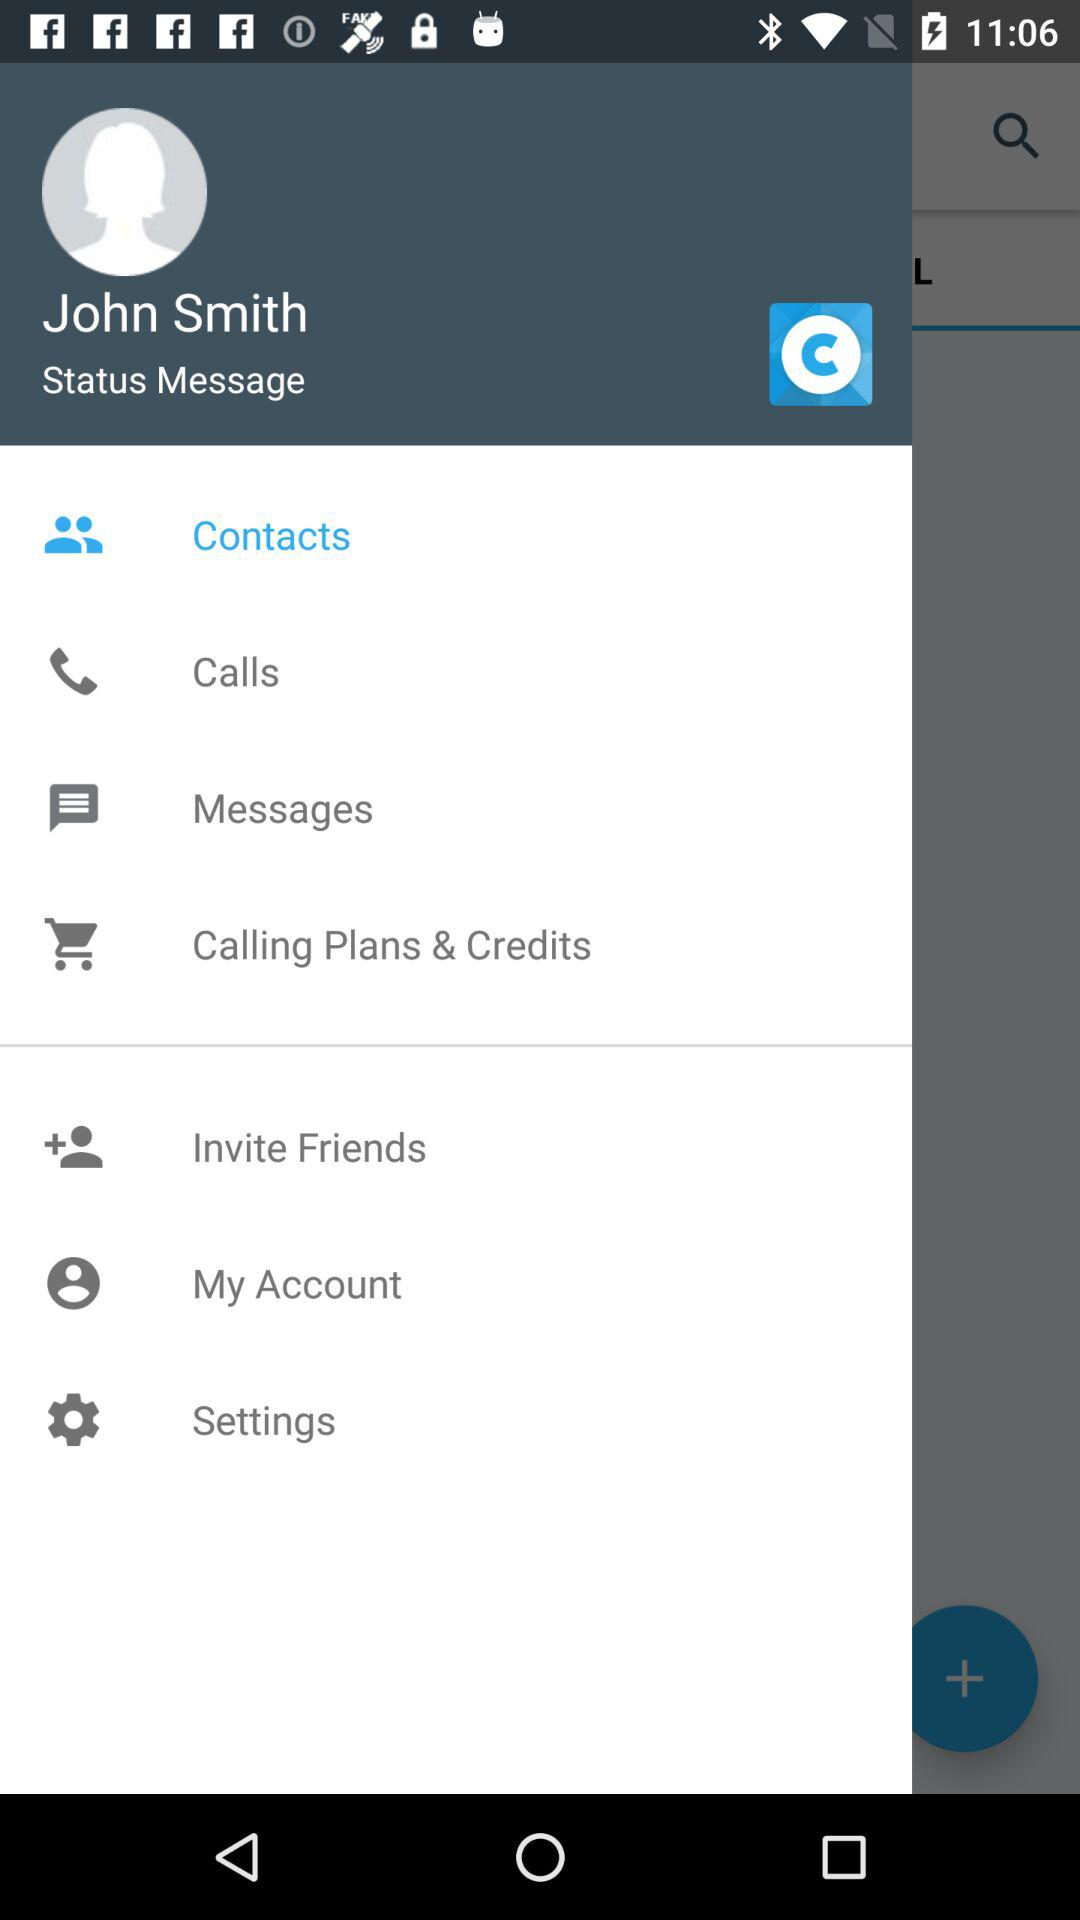What is the user name? The user name is John Smith. 